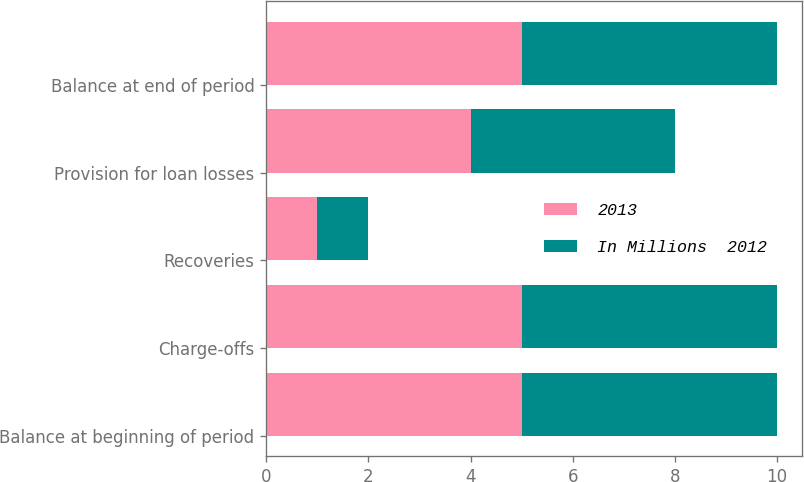<chart> <loc_0><loc_0><loc_500><loc_500><stacked_bar_chart><ecel><fcel>Balance at beginning of period<fcel>Charge-offs<fcel>Recoveries<fcel>Provision for loan losses<fcel>Balance at end of period<nl><fcel>2013<fcel>5<fcel>5<fcel>1<fcel>4<fcel>5<nl><fcel>In Millions  2012<fcel>5<fcel>5<fcel>1<fcel>4<fcel>5<nl></chart> 